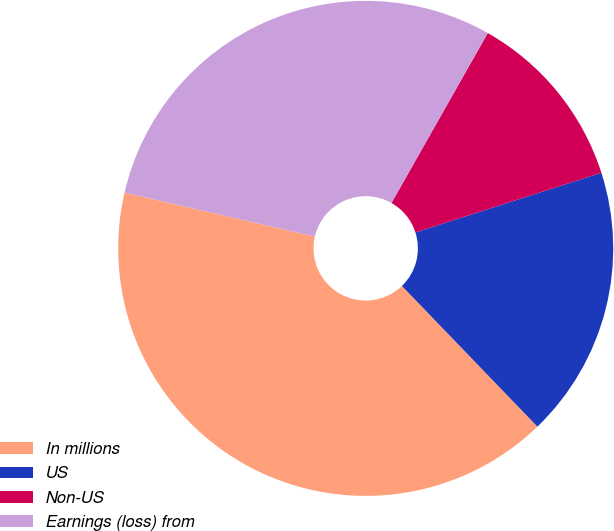Convert chart. <chart><loc_0><loc_0><loc_500><loc_500><pie_chart><fcel>In millions<fcel>US<fcel>Non-US<fcel>Earnings (loss) from<nl><fcel>40.82%<fcel>17.74%<fcel>11.85%<fcel>29.59%<nl></chart> 